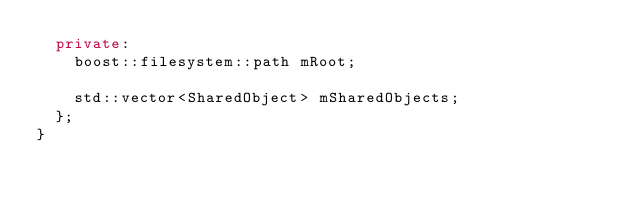Convert code to text. <code><loc_0><loc_0><loc_500><loc_500><_C++_>  private:
    boost::filesystem::path mRoot;

    std::vector<SharedObject> mSharedObjects;
  };
}</code> 